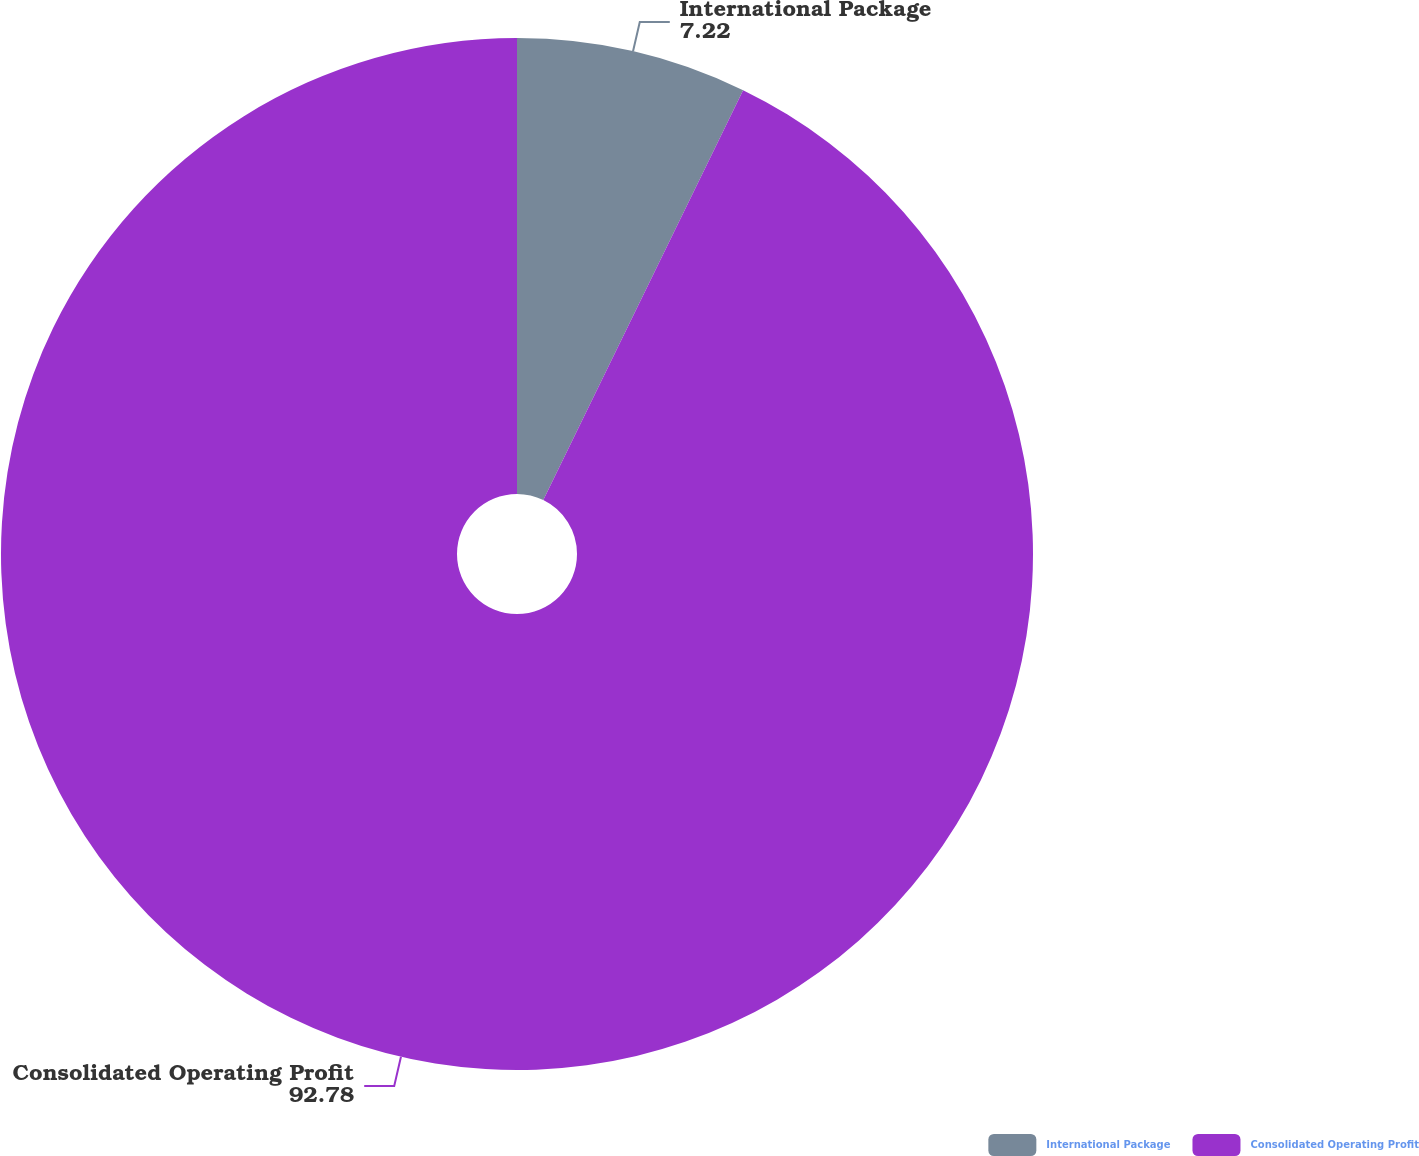Convert chart. <chart><loc_0><loc_0><loc_500><loc_500><pie_chart><fcel>International Package<fcel>Consolidated Operating Profit<nl><fcel>7.22%<fcel>92.78%<nl></chart> 